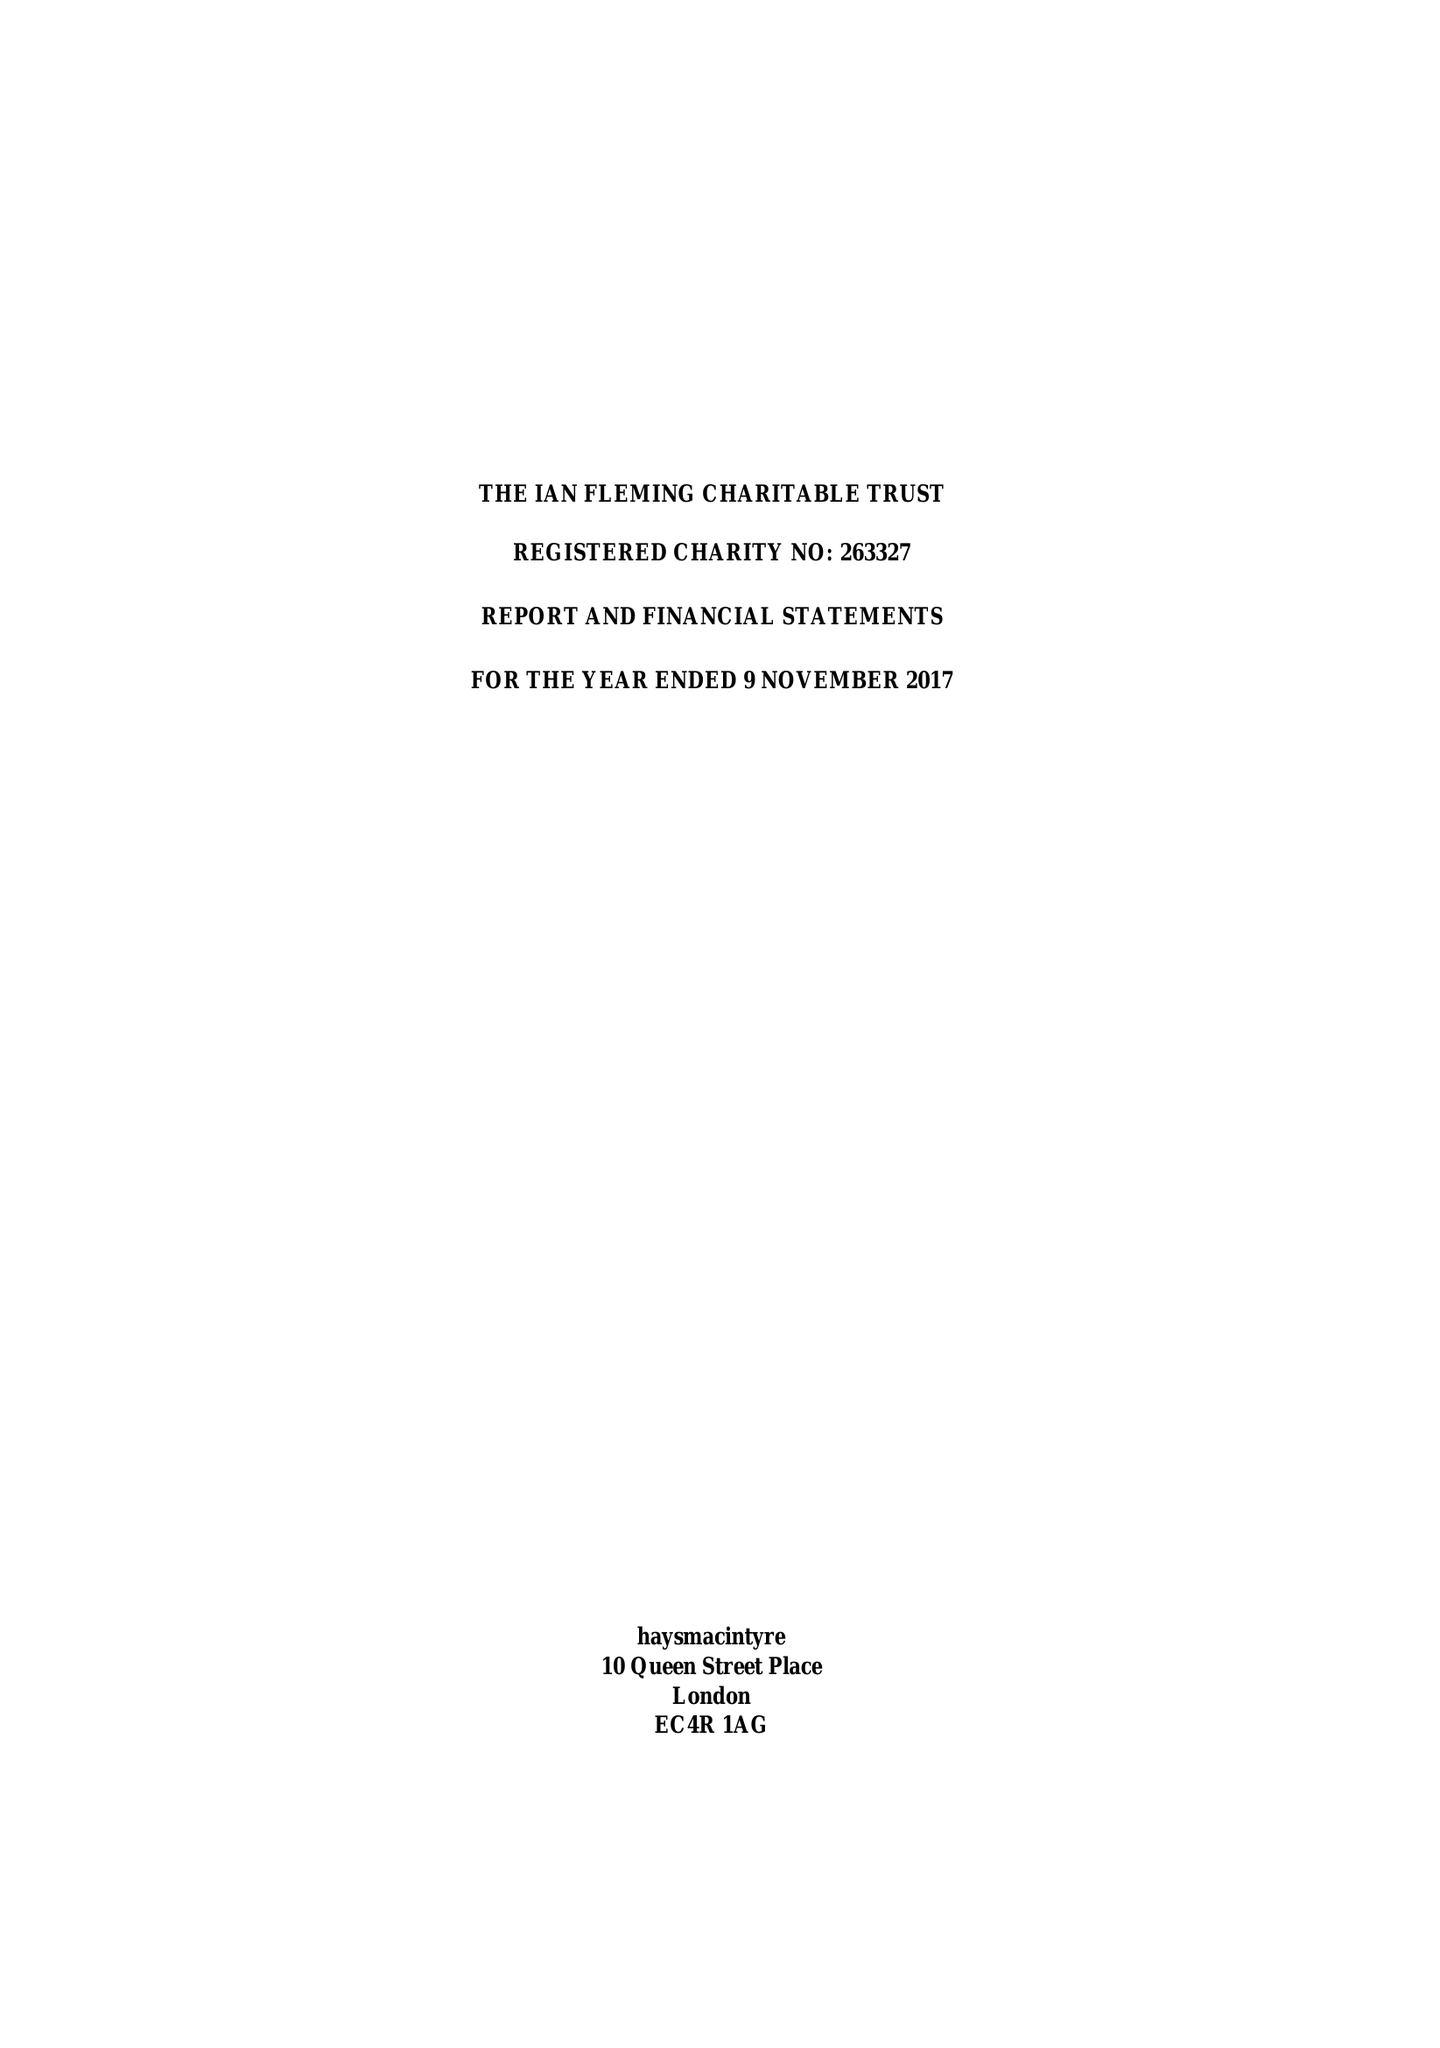What is the value for the report_date?
Answer the question using a single word or phrase. 2017-11-09 